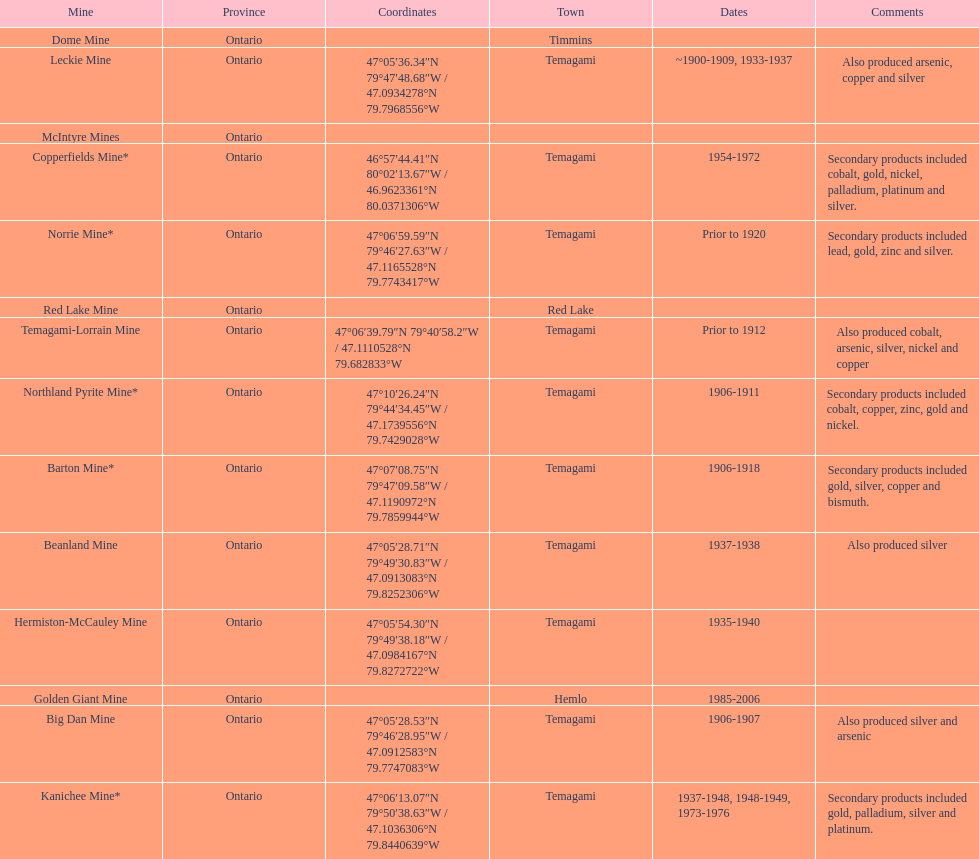Provide the title of a gold mine that functioned for at least ten years. Barton Mine. 